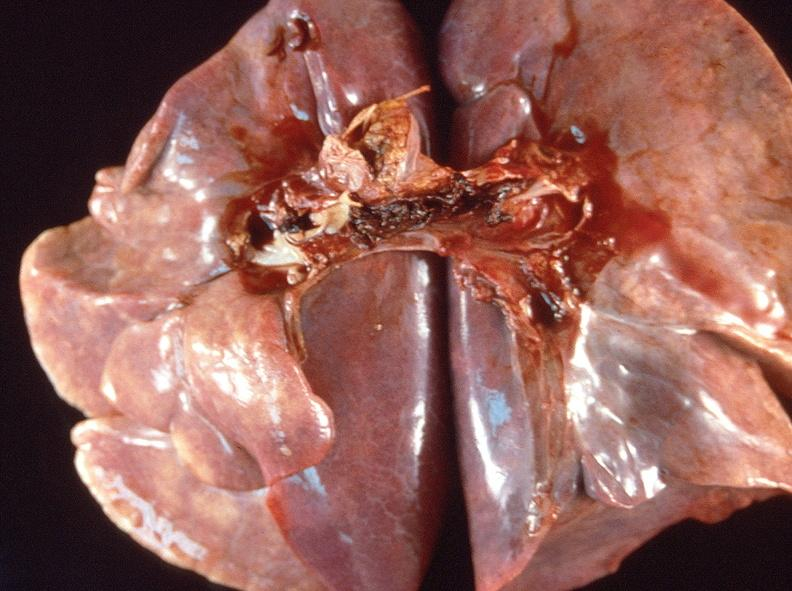s respiratory present?
Answer the question using a single word or phrase. Yes 